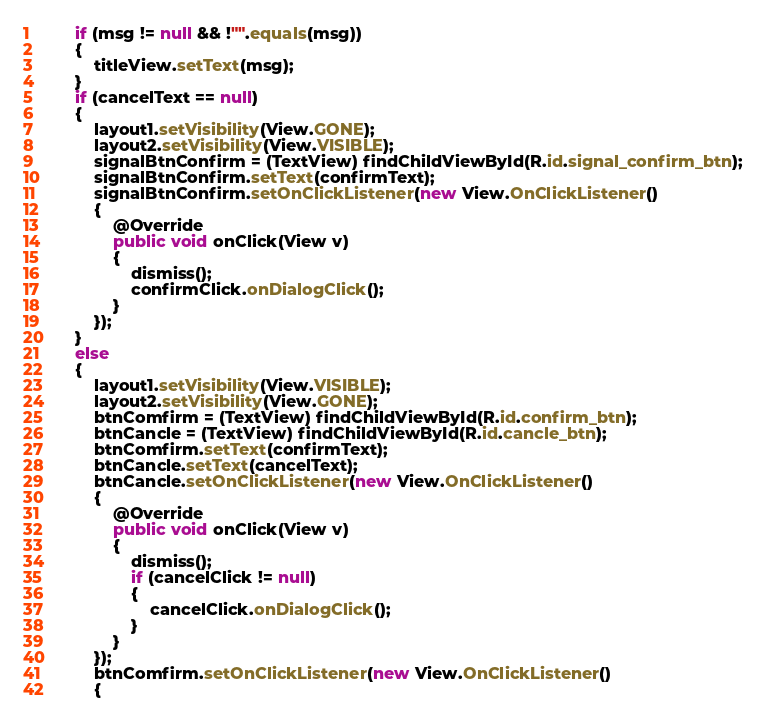<code> <loc_0><loc_0><loc_500><loc_500><_Java_>        if (msg != null && !"".equals(msg))
        {
            titleView.setText(msg);
        }
        if (cancelText == null)
        {
            layout1.setVisibility(View.GONE);
            layout2.setVisibility(View.VISIBLE);
            signalBtnConfirm = (TextView) findChildViewById(R.id.signal_confirm_btn);
            signalBtnConfirm.setText(confirmText);
            signalBtnConfirm.setOnClickListener(new View.OnClickListener()
            {
                @Override
                public void onClick(View v)
                {
                    dismiss();
                    confirmClick.onDialogClick();
                }
            });
        }
        else
        {
            layout1.setVisibility(View.VISIBLE);
            layout2.setVisibility(View.GONE);
            btnComfirm = (TextView) findChildViewById(R.id.confirm_btn);
            btnCancle = (TextView) findChildViewById(R.id.cancle_btn);
            btnComfirm.setText(confirmText);
            btnCancle.setText(cancelText);
            btnCancle.setOnClickListener(new View.OnClickListener()
            {
                @Override
                public void onClick(View v)
                {
                    dismiss();
                    if (cancelClick != null)
                    {
                        cancelClick.onDialogClick();
                    }
                }
            });
            btnComfirm.setOnClickListener(new View.OnClickListener()
            {</code> 